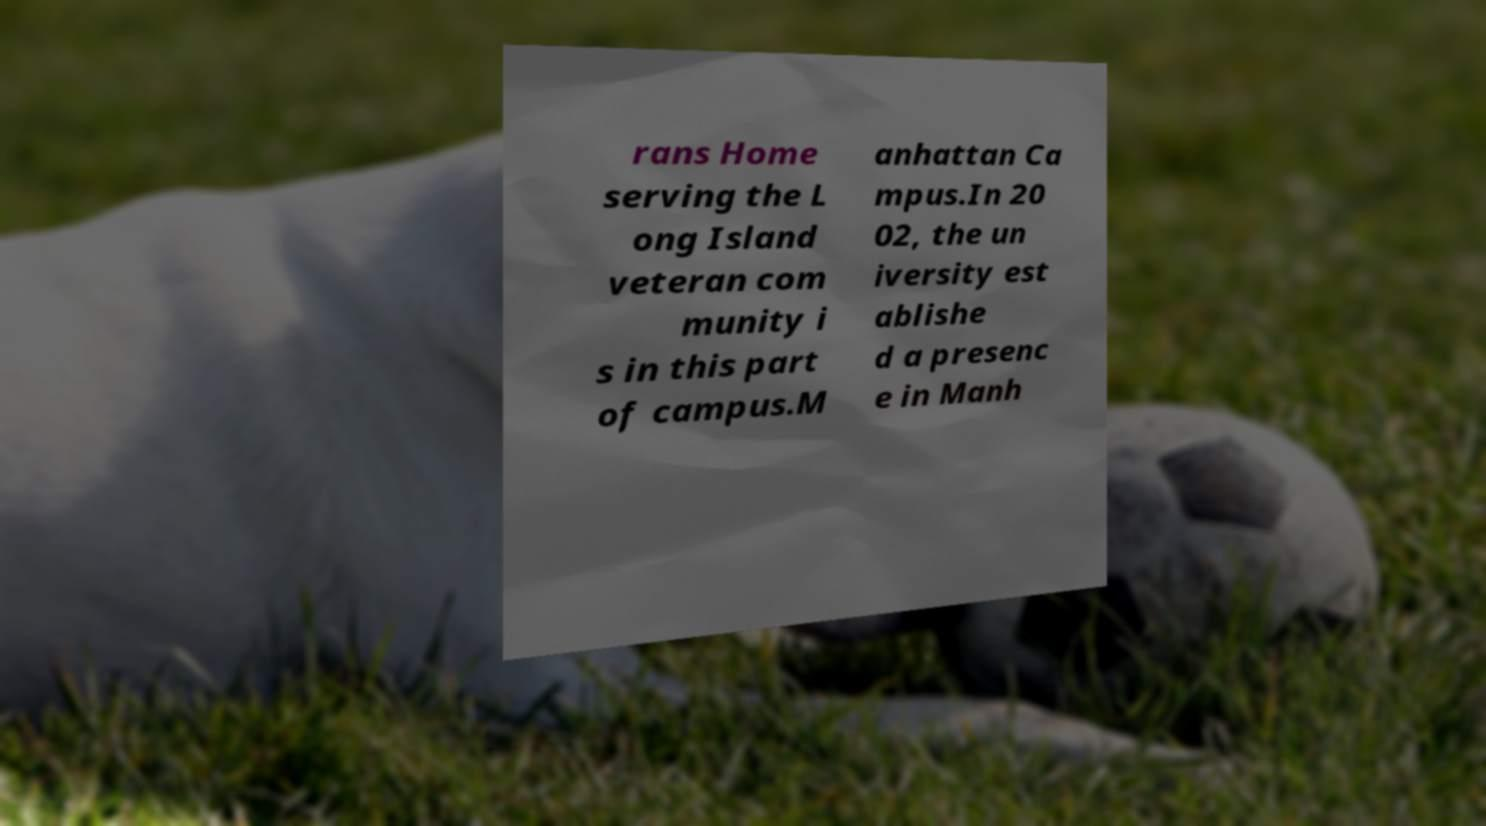Could you extract and type out the text from this image? rans Home serving the L ong Island veteran com munity i s in this part of campus.M anhattan Ca mpus.In 20 02, the un iversity est ablishe d a presenc e in Manh 